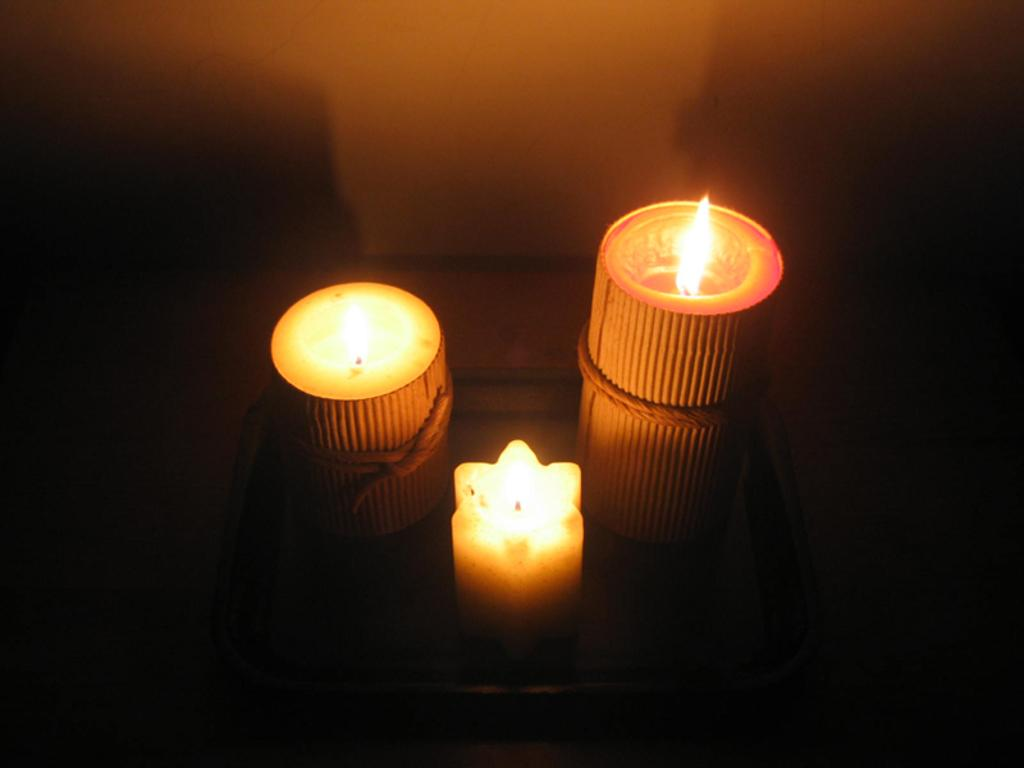How many candles are visible in the image? There are three candles in the image. What is located at the top of the image? There is a wall at the top of the image. What type of spark can be seen coming from the candles in the image? There is no spark visible coming from the candles in the image. What cable is connected to the candles in the image? There is no cable connected to the candles in the image. 